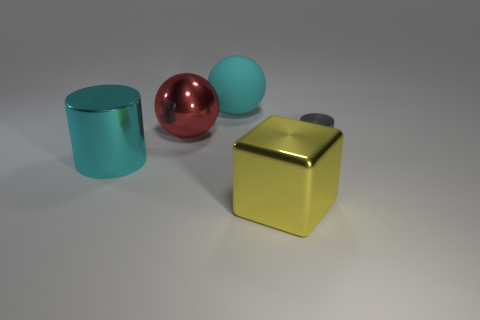Add 3 large green cubes. How many objects exist? 8 Subtract all spheres. How many objects are left? 3 Subtract all small gray things. Subtract all big blue cylinders. How many objects are left? 4 Add 5 small objects. How many small objects are left? 6 Add 4 purple things. How many purple things exist? 4 Subtract 0 yellow balls. How many objects are left? 5 